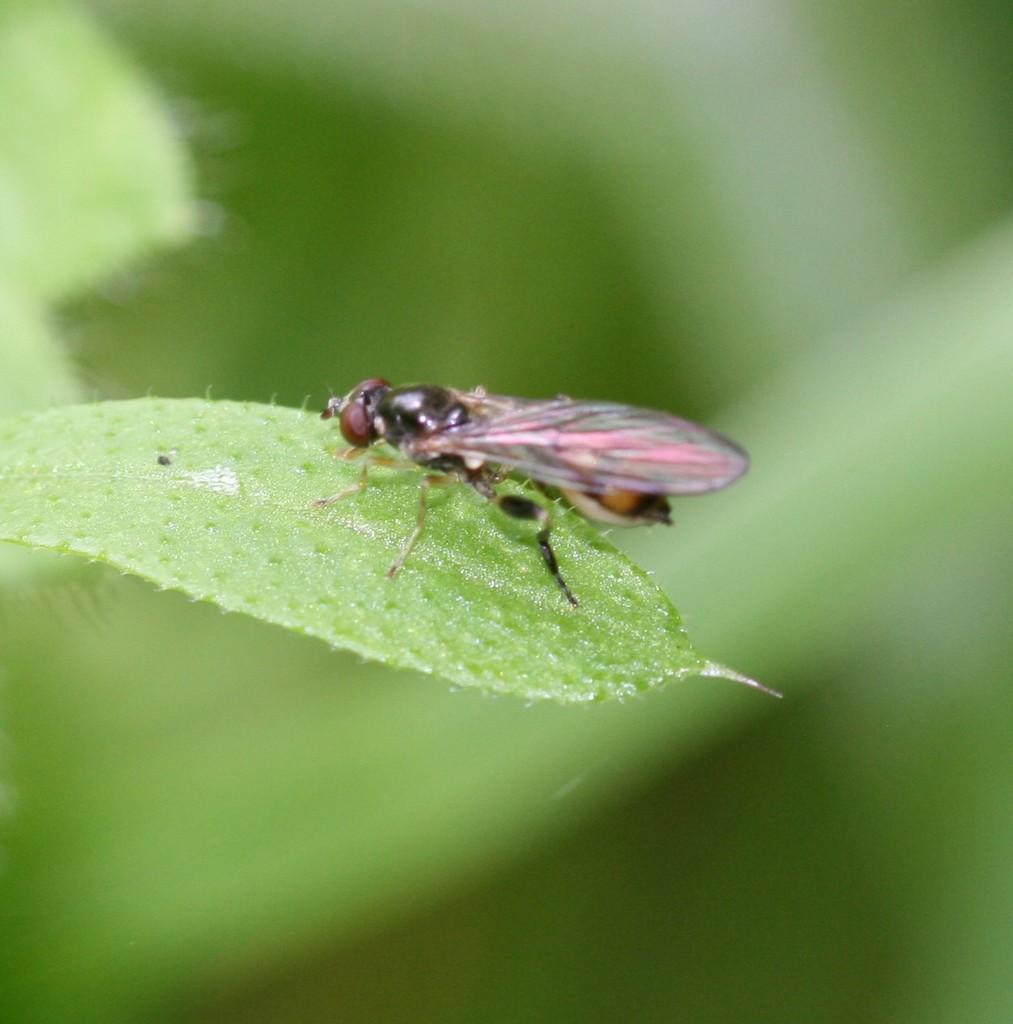How would you summarize this image in a sentence or two? In this image we can see an insect on a leaf. 